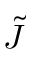<formula> <loc_0><loc_0><loc_500><loc_500>\tilde { J }</formula> 